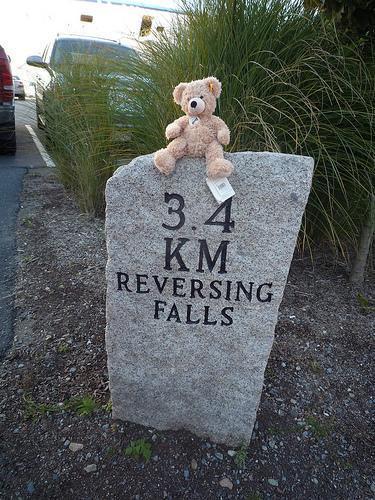How many cars can be seen?
Give a very brief answer. 3. 